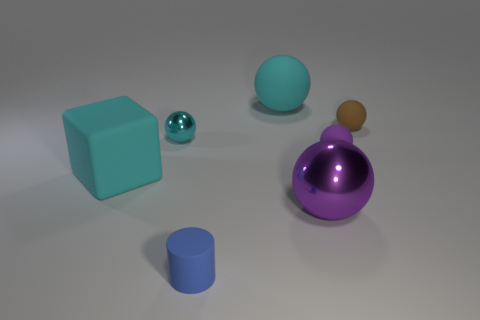Is the cyan metallic object the same shape as the small blue matte thing?
Give a very brief answer. No. What number of big things are red metallic cubes or blue matte things?
Ensure brevity in your answer.  0. Is the number of blue metal cylinders greater than the number of large objects?
Your response must be concise. No. There is a brown thing that is the same material as the large cube; what size is it?
Offer a very short reply. Small. There is a metal thing in front of the small shiny sphere; does it have the same size as the rubber ball in front of the tiny metal thing?
Keep it short and to the point. No. How many objects are either big spheres that are in front of the brown rubber ball or purple matte objects?
Keep it short and to the point. 2. Are there fewer small cyan shiny spheres than blue metal things?
Give a very brief answer. No. What shape is the big rubber thing left of the tiny rubber object on the left side of the cyan matte thing that is on the right side of the tiny cylinder?
Provide a short and direct response. Cube. What shape is the tiny thing that is the same color as the matte block?
Offer a very short reply. Sphere. Are there any red blocks?
Offer a very short reply. No. 